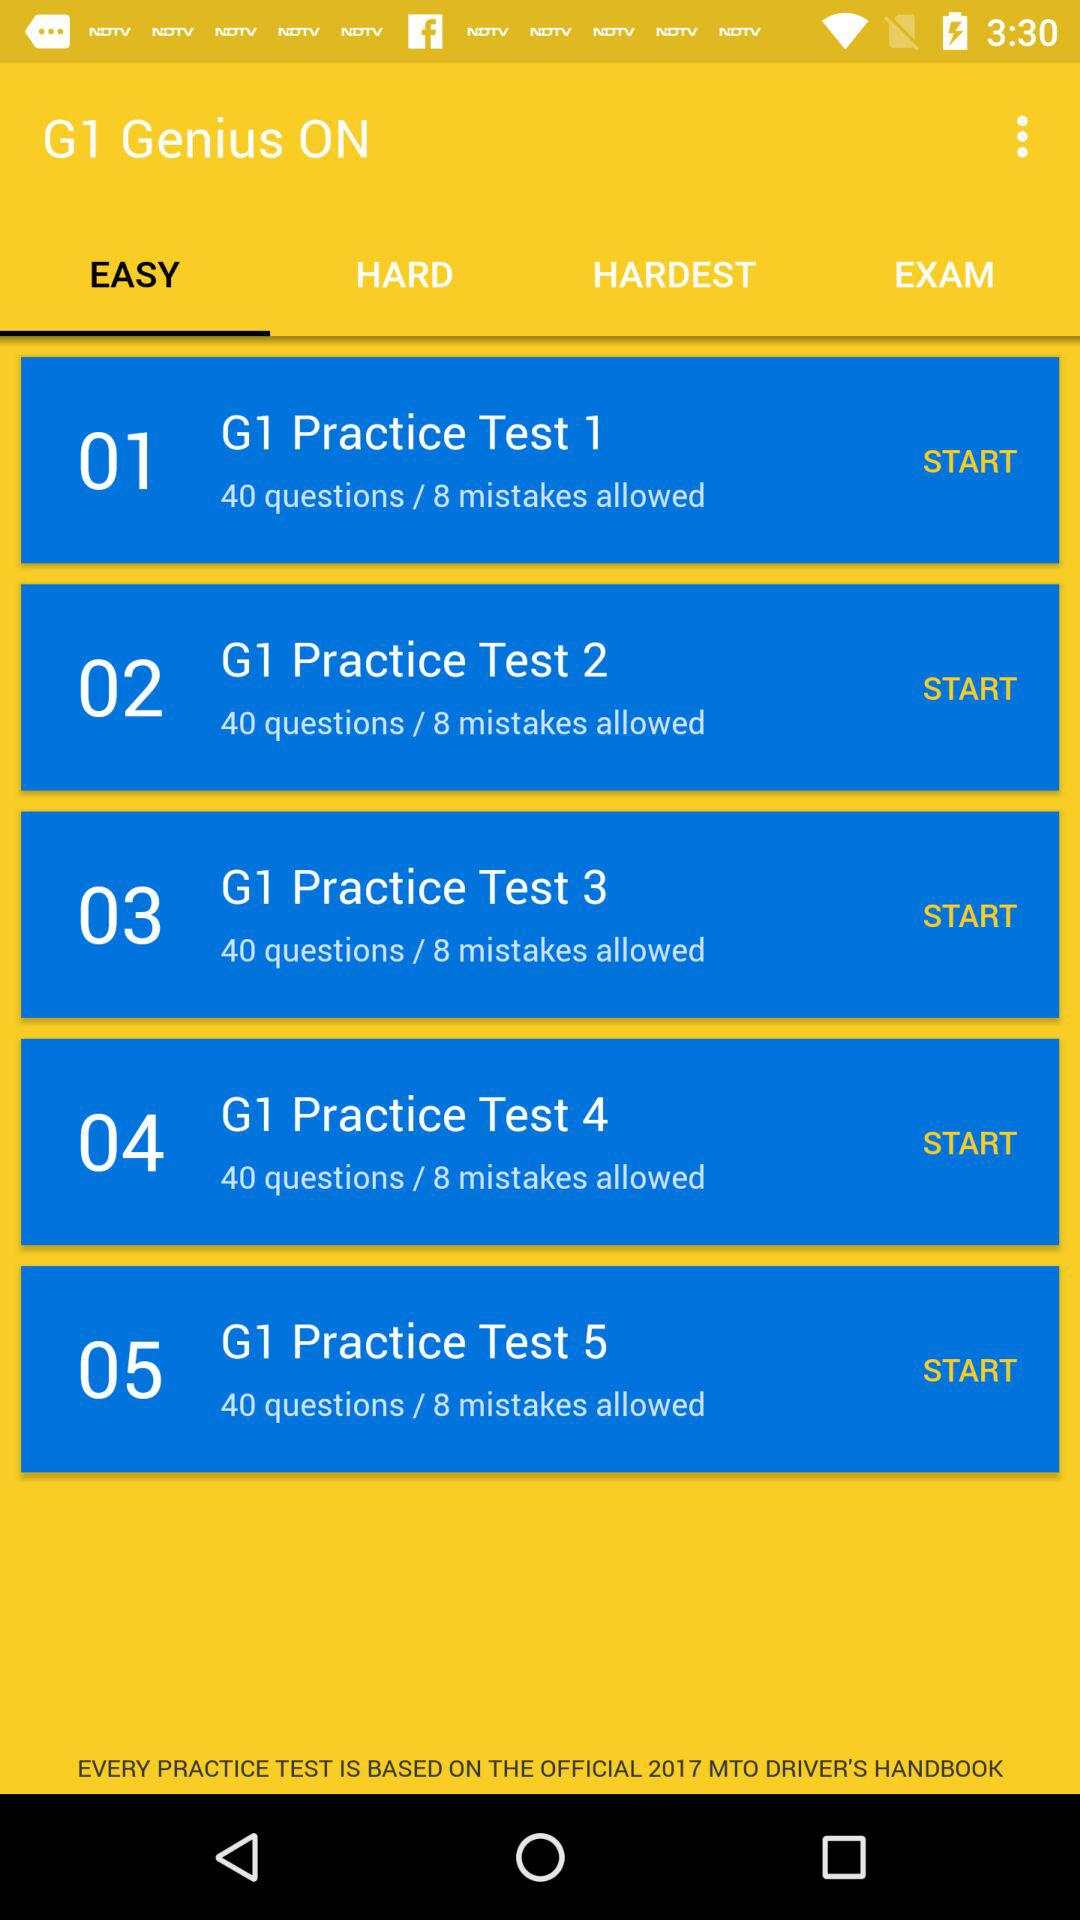How many mistakes are allowed in "G1 Practice Test 5"? There are 8 mistakes allowed in "G1 Practice Test 5". 